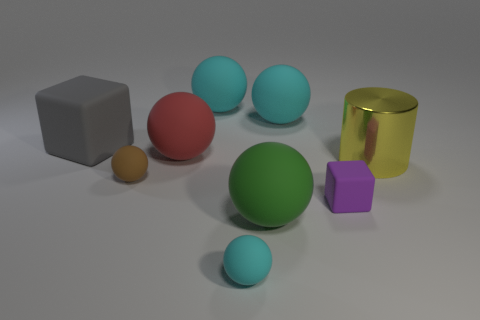Subtract all large matte spheres. How many spheres are left? 2 Subtract all brown cylinders. How many cyan balls are left? 3 Add 1 small blue rubber cylinders. How many objects exist? 10 Subtract all brown spheres. How many spheres are left? 5 Subtract 4 spheres. How many spheres are left? 2 Subtract all cubes. How many objects are left? 7 Subtract 1 brown balls. How many objects are left? 8 Subtract all green spheres. Subtract all green cubes. How many spheres are left? 5 Subtract all small things. Subtract all large red rubber balls. How many objects are left? 5 Add 7 big cylinders. How many big cylinders are left? 8 